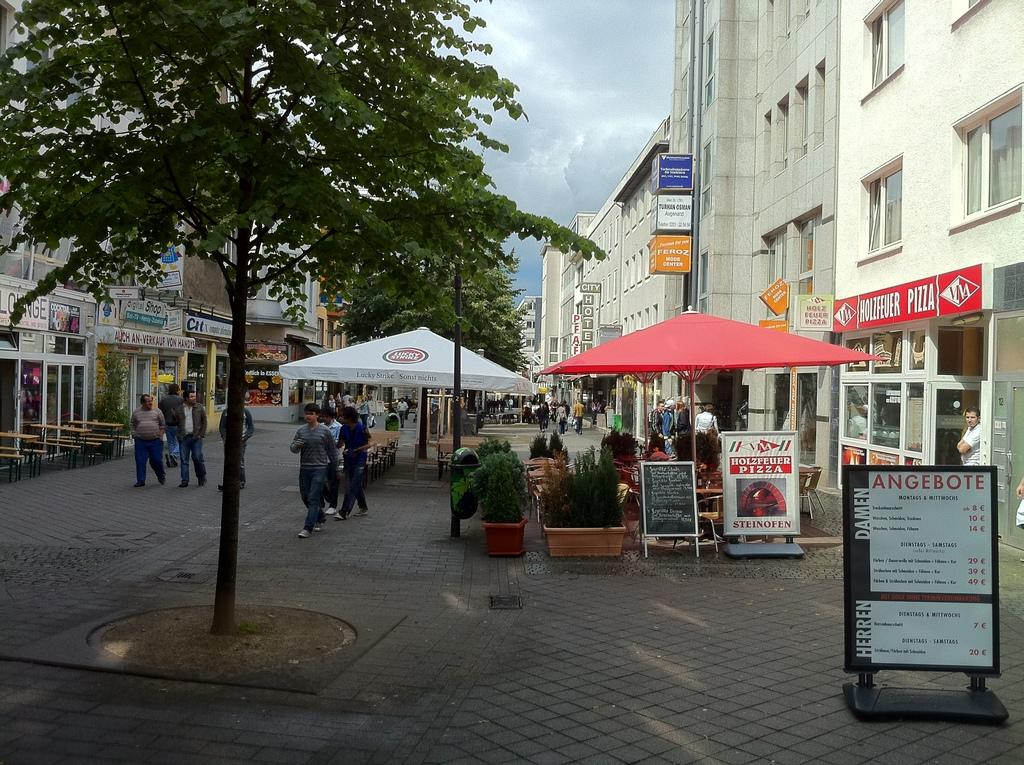What type of structures can be seen in the image? There are buildings in the image. What natural elements are present in the image? There are trees in the image. What temporary shelters can be seen in the image? There are tents in the image. Can you describe the people in the image? There is a group of people in the image. What type of signage is visible in the background of the image? There are hoardings in the background of the image. What can be seen in the sky in the image? There are clouds visible in the background of the image. Where is the cobweb located in the image? There is no cobweb present in the image. What type of beast can be seen interacting with the group of people in the image? There is no beast present in the image; only the group of people, buildings, trees, tents, hoardings, and clouds are visible. 